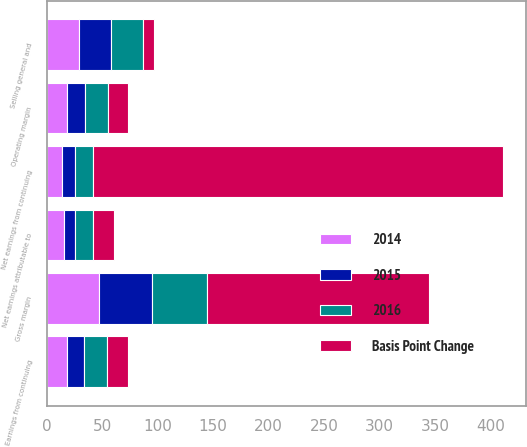Convert chart. <chart><loc_0><loc_0><loc_500><loc_500><stacked_bar_chart><ecel><fcel>Gross margin<fcel>Selling general and<fcel>Operating margin<fcel>Earnings from continuing<fcel>Net earnings from continuing<fcel>Net earnings attributable to<nl><fcel>2016<fcel>49.6<fcel>29<fcel>20.6<fcel>20.5<fcel>15.4<fcel>16.1<nl><fcel>Basis Point Change<fcel>200<fcel>10<fcel>18.7<fcel>18.7<fcel>370<fcel>18.7<nl><fcel>2015<fcel>47.6<fcel>29.1<fcel>15.6<fcel>15.6<fcel>11.7<fcel>9.9<nl><fcel>2014<fcel>47.5<fcel>28.8<fcel>18.7<fcel>18.2<fcel>14.3<fcel>15.6<nl></chart> 